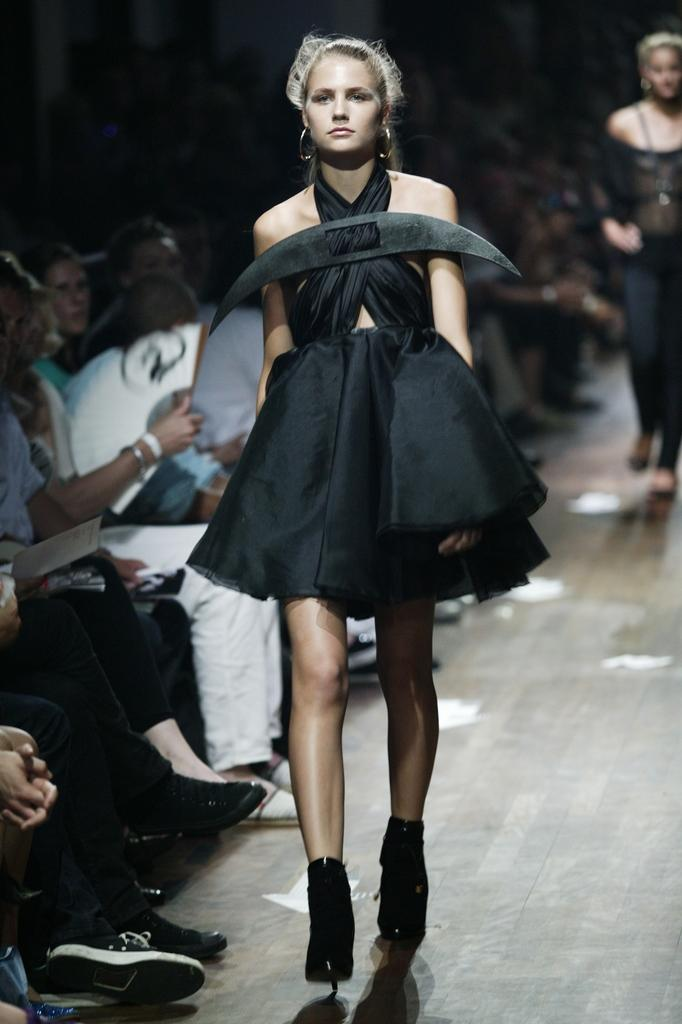Who is the main subject in the image? There is a woman in the image. What is the woman doing in the image? The woman is walking on a ramp in the image. What type of event is taking place in the image? It is a fashion show. Are there any spectators in the image? Yes, there are people sitting and watching the show. How is the background of the woman depicted in the image? The background of the woman is blurred. What type of grain is being harvested by the woman's daughter in the image? There is no mention of a daughter or grain in the image; the main subject is a woman walking on a ramp during a fashion show. 